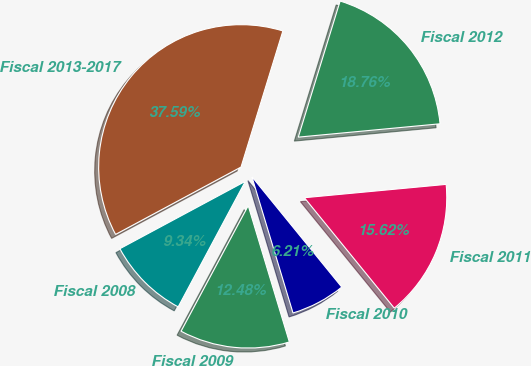Convert chart. <chart><loc_0><loc_0><loc_500><loc_500><pie_chart><fcel>Fiscal 2008<fcel>Fiscal 2009<fcel>Fiscal 2010<fcel>Fiscal 2011<fcel>Fiscal 2012<fcel>Fiscal 2013-2017<nl><fcel>9.34%<fcel>12.48%<fcel>6.21%<fcel>15.62%<fcel>18.76%<fcel>37.59%<nl></chart> 